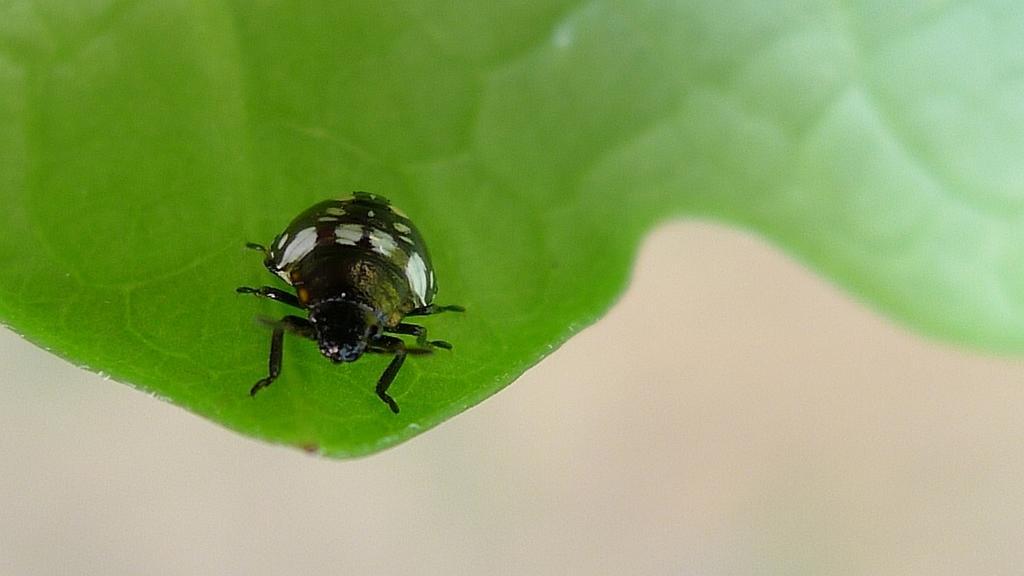In one or two sentences, can you explain what this image depicts? In the picture we can see some insect which is black in color is on the leaf which is green in color. 